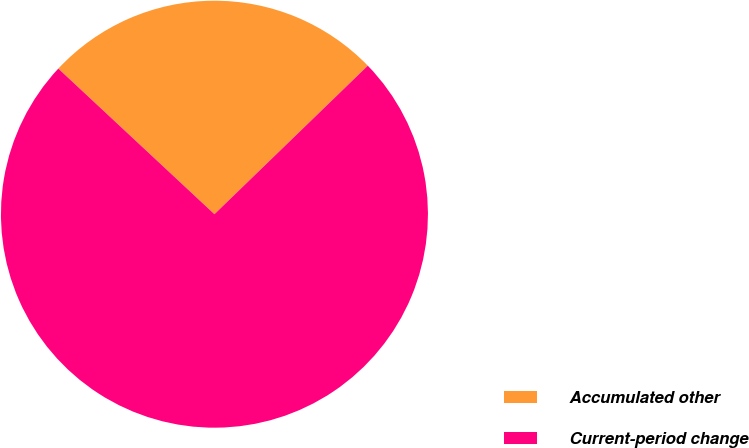Convert chart. <chart><loc_0><loc_0><loc_500><loc_500><pie_chart><fcel>Accumulated other<fcel>Current-period change<nl><fcel>25.81%<fcel>74.19%<nl></chart> 